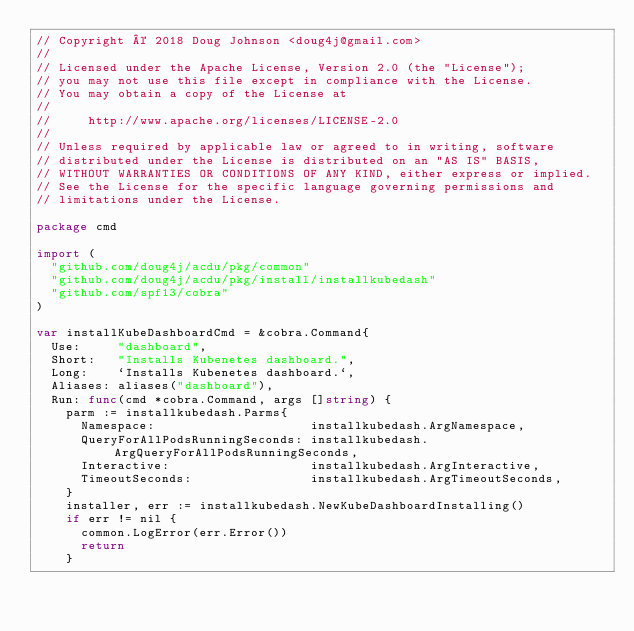Convert code to text. <code><loc_0><loc_0><loc_500><loc_500><_Go_>// Copyright © 2018 Doug Johnson <doug4j@gmail.com>
//
// Licensed under the Apache License, Version 2.0 (the "License");
// you may not use this file except in compliance with the License.
// You may obtain a copy of the License at
//
//     http://www.apache.org/licenses/LICENSE-2.0
//
// Unless required by applicable law or agreed to in writing, software
// distributed under the License is distributed on an "AS IS" BASIS,
// WITHOUT WARRANTIES OR CONDITIONS OF ANY KIND, either express or implied.
// See the License for the specific language governing permissions and
// limitations under the License.

package cmd

import (
	"github.com/doug4j/acdu/pkg/common"
	"github.com/doug4j/acdu/pkg/install/installkubedash"
	"github.com/spf13/cobra"
)

var installKubeDashboardCmd = &cobra.Command{
	Use:     "dashboard",
	Short:   "Installs Kubenetes dashboard.",
	Long:    `Installs Kubenetes dashboard.`,
	Aliases: aliases("dashboard"),
	Run: func(cmd *cobra.Command, args []string) {
		parm := installkubedash.Parms{
			Namespace:                     installkubedash.ArgNamespace,
			QueryForAllPodsRunningSeconds: installkubedash.ArgQueryForAllPodsRunningSeconds,
			Interactive:                   installkubedash.ArgInteractive,
			TimeoutSeconds:                installkubedash.ArgTimeoutSeconds,
		}
		installer, err := installkubedash.NewKubeDashboardInstalling()
		if err != nil {
			common.LogError(err.Error())
			return
		}</code> 